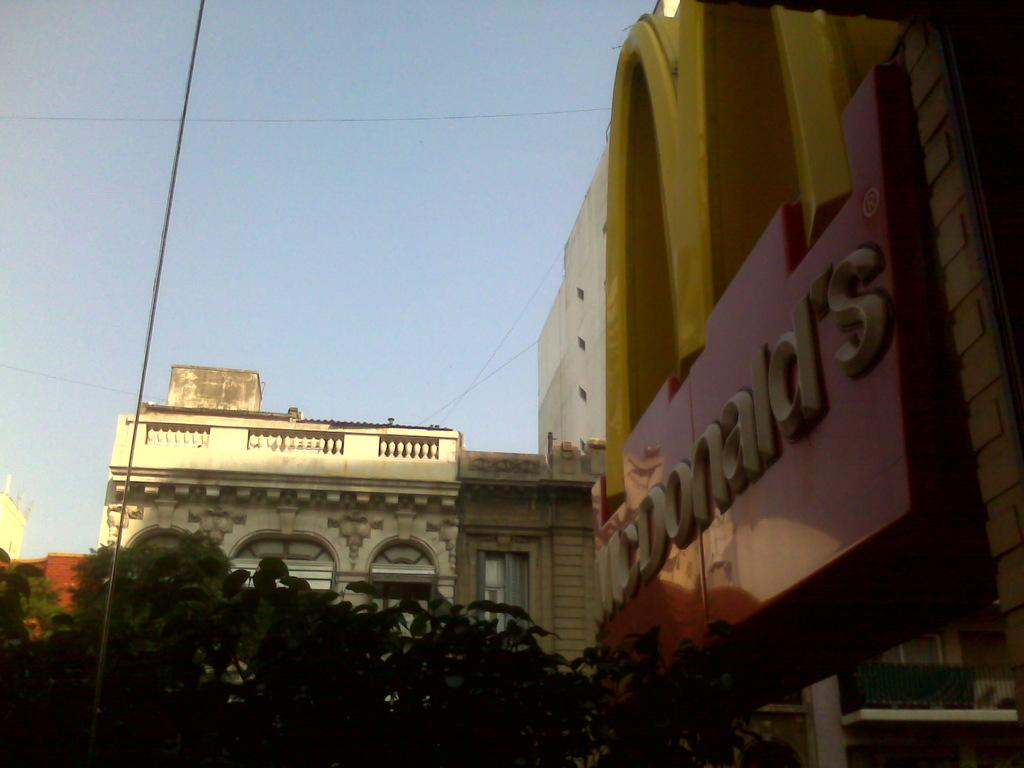What type of structures can be seen in the image? There are buildings in the image. What is written in the image? There is something written in the image. What type of vegetation is visible in the image? There are leaves visible in the image. What else can be seen in the image besides the buildings? There are wires in the image. What is visible in the background of the image? The sky is visible in the background of the image. What type of celery is being used to grade the angle of the buildings in the image? There is no celery present in the image, nor is there any indication of grading or angles related to the buildings. 